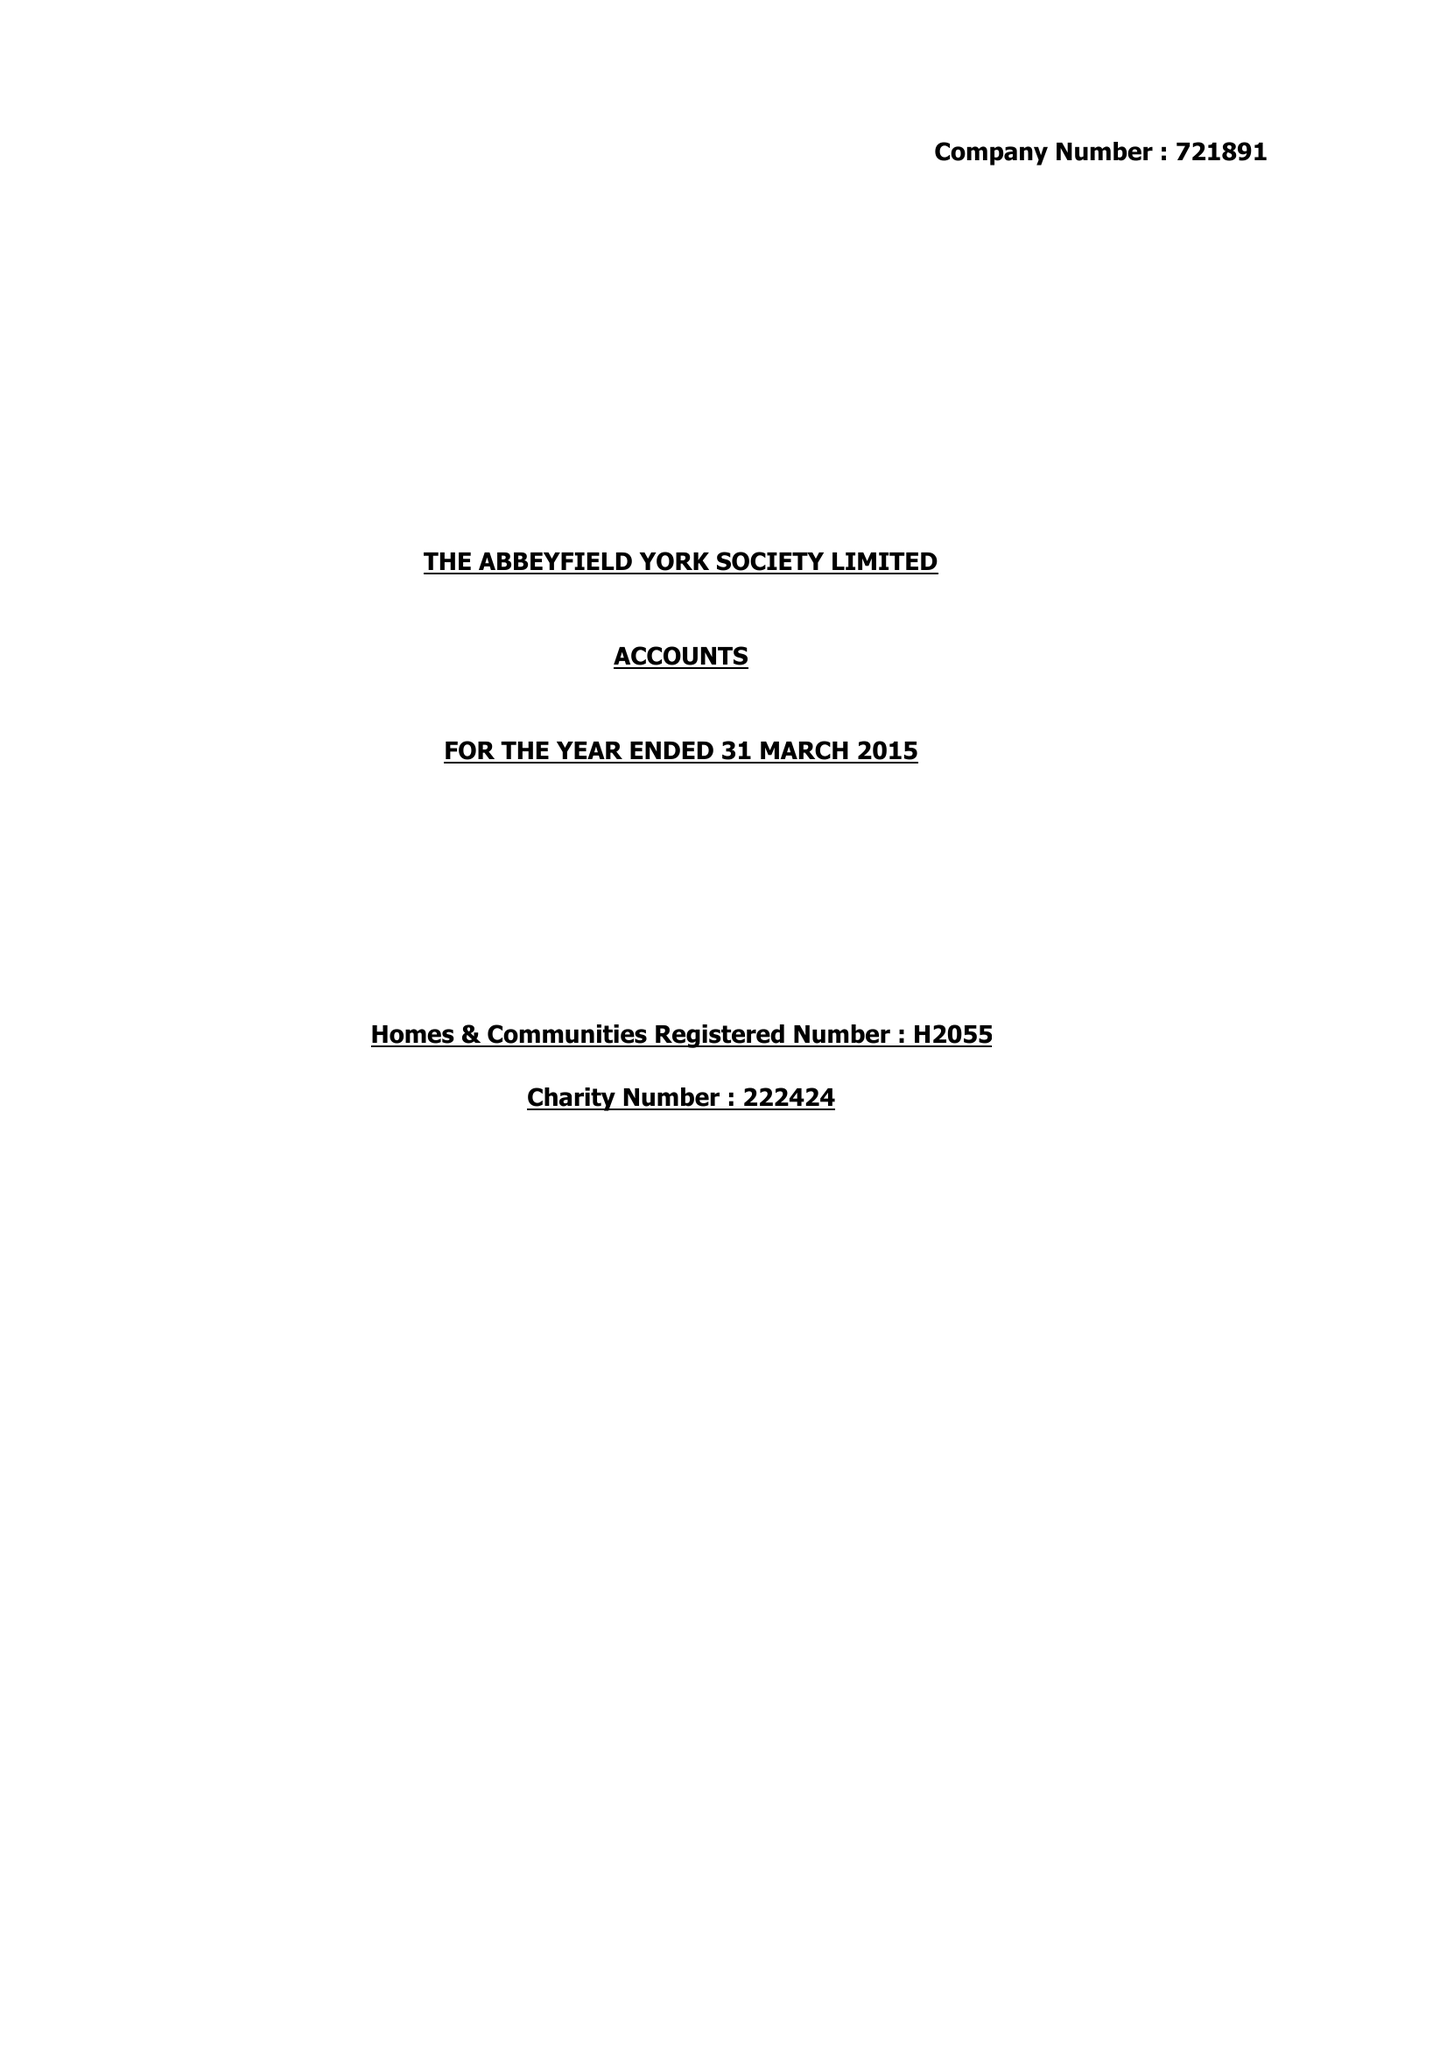What is the value for the spending_annually_in_british_pounds?
Answer the question using a single word or phrase. 394321.00 